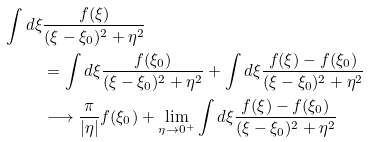Convert formula to latex. <formula><loc_0><loc_0><loc_500><loc_500>\int d \xi & \frac { f ( \xi ) } { ( \xi - \xi _ { 0 } ) ^ { 2 } + \eta ^ { 2 } } \\ & = \int d \xi \frac { f ( \xi _ { 0 } ) } { ( \xi - \xi _ { 0 } ) ^ { 2 } + \eta ^ { 2 } } + \int d \xi \frac { f ( \xi ) - f ( \xi _ { 0 } ) } { ( \xi - \xi _ { 0 } ) ^ { 2 } + \eta ^ { 2 } } \\ & \longrightarrow \frac { \pi } { | \eta | } f ( \xi _ { 0 } ) + \lim _ { \eta \rightarrow 0 ^ { + } } \int d \xi \frac { f ( \xi ) - f ( \xi _ { 0 } ) } { ( \xi - \xi _ { 0 } ) ^ { 2 } + \eta ^ { 2 } }</formula> 